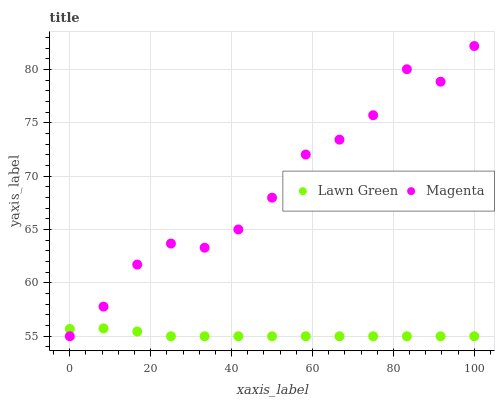Does Lawn Green have the minimum area under the curve?
Answer yes or no. Yes. Does Magenta have the maximum area under the curve?
Answer yes or no. Yes. Does Magenta have the minimum area under the curve?
Answer yes or no. No. Is Lawn Green the smoothest?
Answer yes or no. Yes. Is Magenta the roughest?
Answer yes or no. Yes. Is Magenta the smoothest?
Answer yes or no. No. Does Lawn Green have the lowest value?
Answer yes or no. Yes. Does Magenta have the highest value?
Answer yes or no. Yes. Does Magenta intersect Lawn Green?
Answer yes or no. Yes. Is Magenta less than Lawn Green?
Answer yes or no. No. Is Magenta greater than Lawn Green?
Answer yes or no. No. 